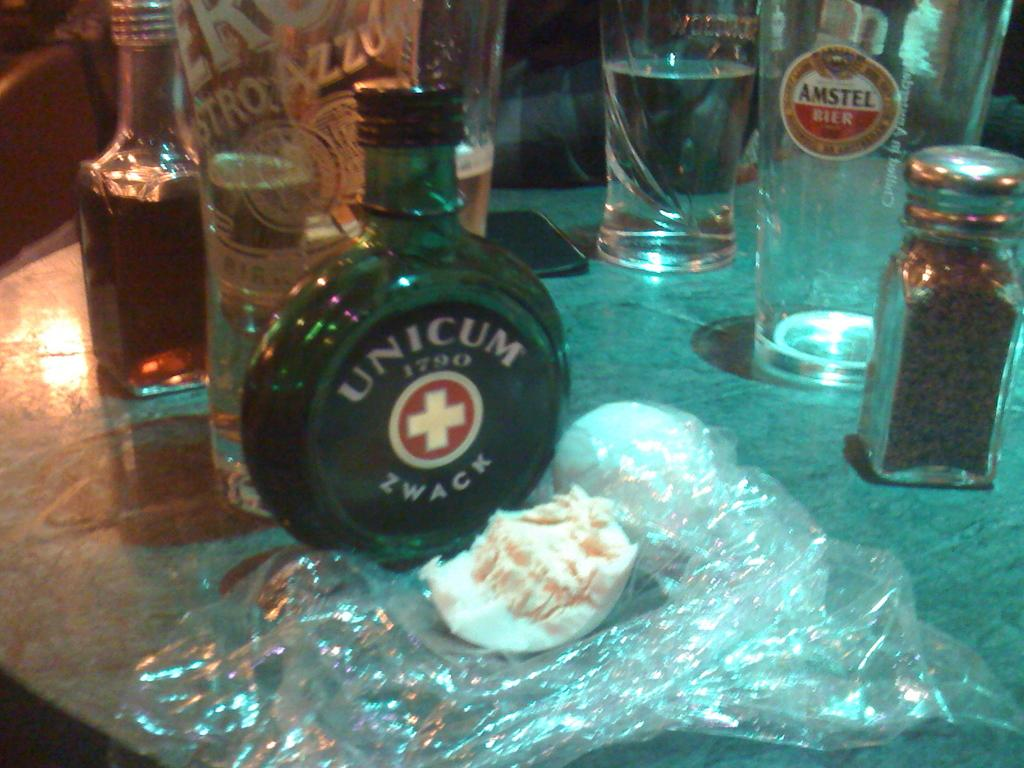<image>
Provide a brief description of the given image. A bottle of Unicum Zwack on a table with glasses and a pepper shaker. 